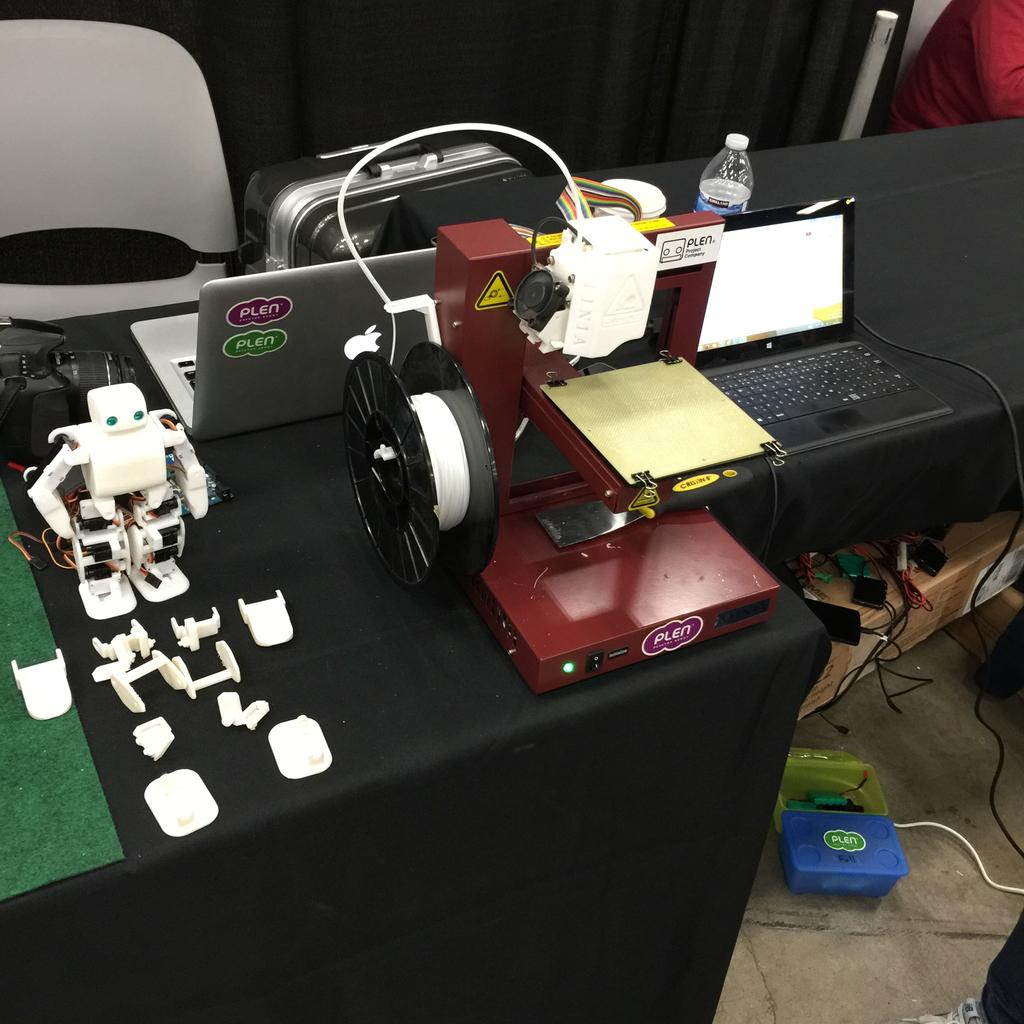What is the main piece of furniture in the image? There is a table in the image. What electronic devices are on the table? There are laptops on the table. What other items can be seen on the table? There is a bottle and a toy on the table, as well as unspecified objects. What is on the floor in the image? There are boxes on the floor. What type of seating is in the image? There is a chair in the image. What is the color of the background in the image? The background of the image is black. How many ladybugs are crawling on the laptops in the image? There are no ladybugs present in the image; only laptops, a bottle, a toy, unspecified objects, boxes, and a chair are visible. What type of beast is lurking in the background of the image? There is no beast present in the image; the background is black. 